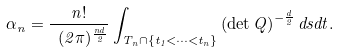<formula> <loc_0><loc_0><loc_500><loc_500>\alpha _ { n } = \frac { n ! } { \ ( 2 \pi ) ^ { \frac { n d } { 2 } } } \int _ { T _ { n } \cap \{ t _ { 1 } < \cdots < t _ { n } \} } \left ( \det Q \right ) ^ { - \frac { d } { 2 } } d s d t .</formula> 